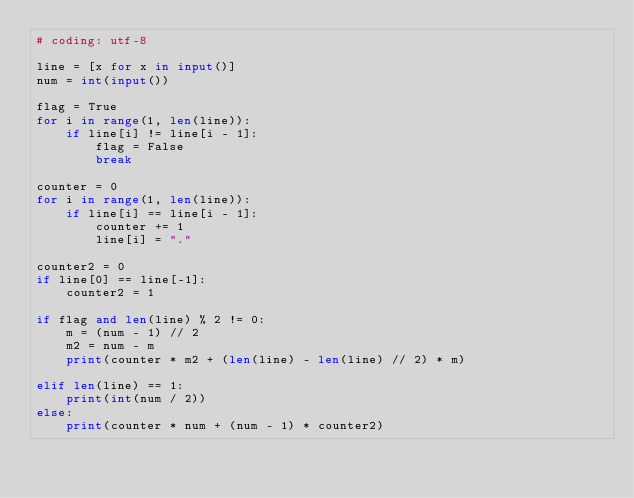Convert code to text. <code><loc_0><loc_0><loc_500><loc_500><_Python_># coding: utf-8

line = [x for x in input()]
num = int(input())

flag = True
for i in range(1, len(line)):
    if line[i] != line[i - 1]:
        flag = False
        break

counter = 0
for i in range(1, len(line)):
    if line[i] == line[i - 1]:
        counter += 1
        line[i] = "."

counter2 = 0
if line[0] == line[-1]:
    counter2 = 1

if flag and len(line) % 2 != 0:
    m = (num - 1) // 2
    m2 = num - m
    print(counter * m2 + (len(line) - len(line) // 2) * m)

elif len(line) == 1:
    print(int(num / 2))
else:
    print(counter * num + (num - 1) * counter2)</code> 